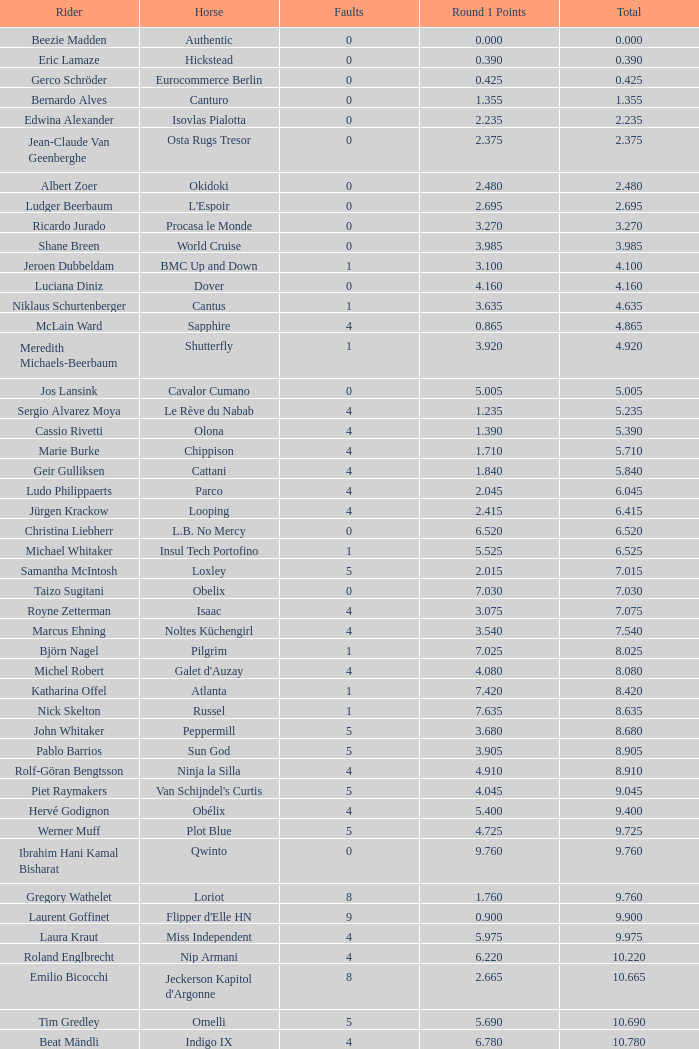What is the greatest total for a horse belonging to carlson? 29.545. 